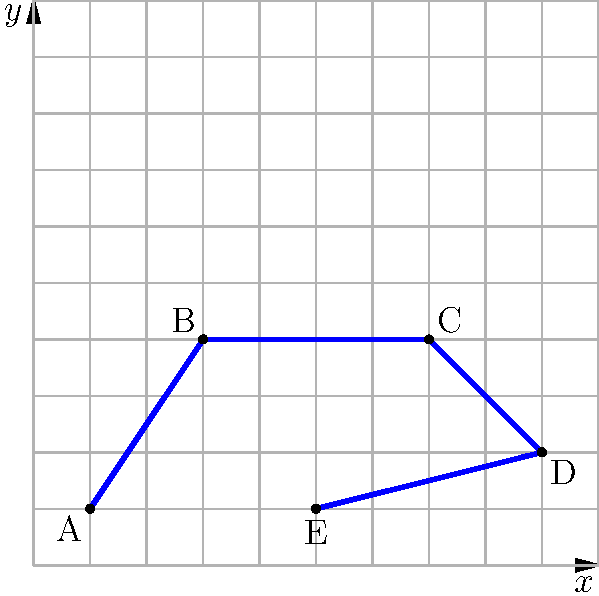In a dog agility course, a trainer has plotted the path of a dog's run using coordinate geometry. The path consists of line segments connecting points A(1,1), B(3,4), C(7,4), D(9,2), and E(5,1) in order. Calculate the total distance the dog runs along this path, rounded to two decimal places. To find the total distance the dog runs, we need to calculate the length of each line segment and sum them up. We'll use the distance formula between two points: $d = \sqrt{(x_2-x_1)^2 + (y_2-y_1)^2}$

1. Distance from A to B:
   $d_{AB} = \sqrt{(3-1)^2 + (4-1)^2} = \sqrt{4 + 9} = \sqrt{13}$

2. Distance from B to C:
   $d_{BC} = \sqrt{(7-3)^2 + (4-4)^2} = \sqrt{16 + 0} = 4$

3. Distance from C to D:
   $d_{CD} = \sqrt{(9-7)^2 + (2-4)^2} = \sqrt{4 + 4} = \sqrt{8} = 2\sqrt{2}$

4. Distance from D to E:
   $d_{DE} = \sqrt{(5-9)^2 + (1-2)^2} = \sqrt{16 + 1} = \sqrt{17}$

Now, let's sum up all these distances:

$d_{total} = \sqrt{13} + 4 + 2\sqrt{2} + \sqrt{17}$

Using a calculator and rounding to two decimal places:

$d_{total} \approx 3.61 + 4 + 2.83 + 4.12 = 14.56$
Answer: 14.56 units 